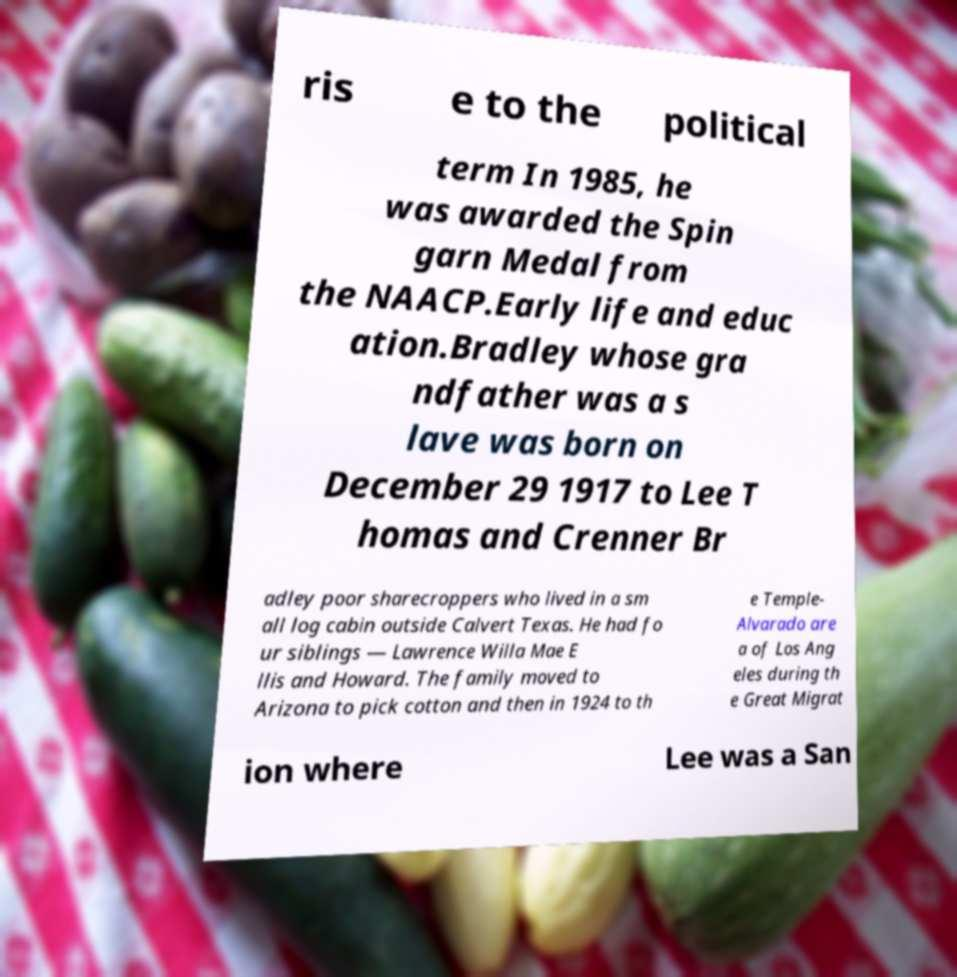Please read and relay the text visible in this image. What does it say? ris e to the political term In 1985, he was awarded the Spin garn Medal from the NAACP.Early life and educ ation.Bradley whose gra ndfather was a s lave was born on December 29 1917 to Lee T homas and Crenner Br adley poor sharecroppers who lived in a sm all log cabin outside Calvert Texas. He had fo ur siblings — Lawrence Willa Mae E llis and Howard. The family moved to Arizona to pick cotton and then in 1924 to th e Temple- Alvarado are a of Los Ang eles during th e Great Migrat ion where Lee was a San 